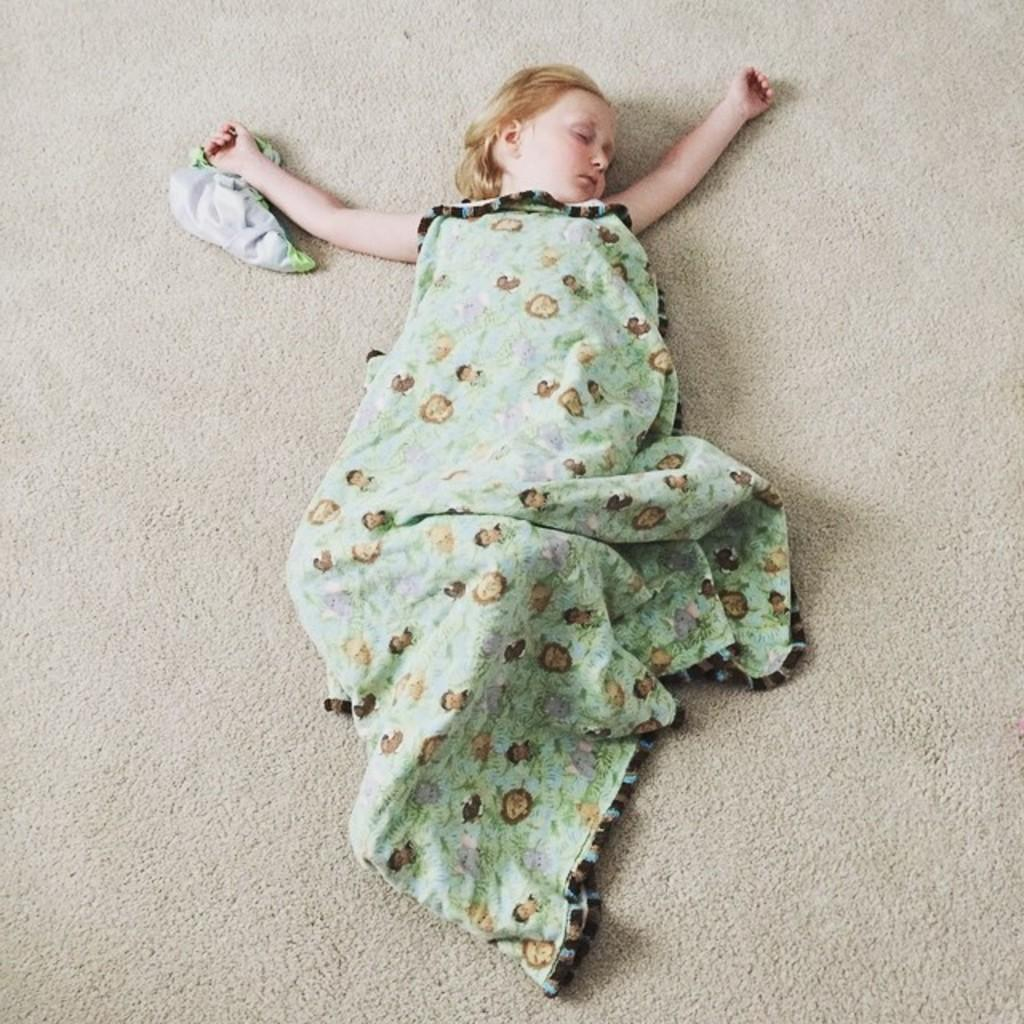What is the main subject of the image? There is a baby in the image. Where is the baby located in the image? The baby is lying on the floor. What is on the floor with the baby? There is a blanket on the floor. What other item can be seen in the image? There is a piece of cloth in the image. What does the minister say to the baby in the image? There is no minister present in the image, so it is not possible to answer that question. 